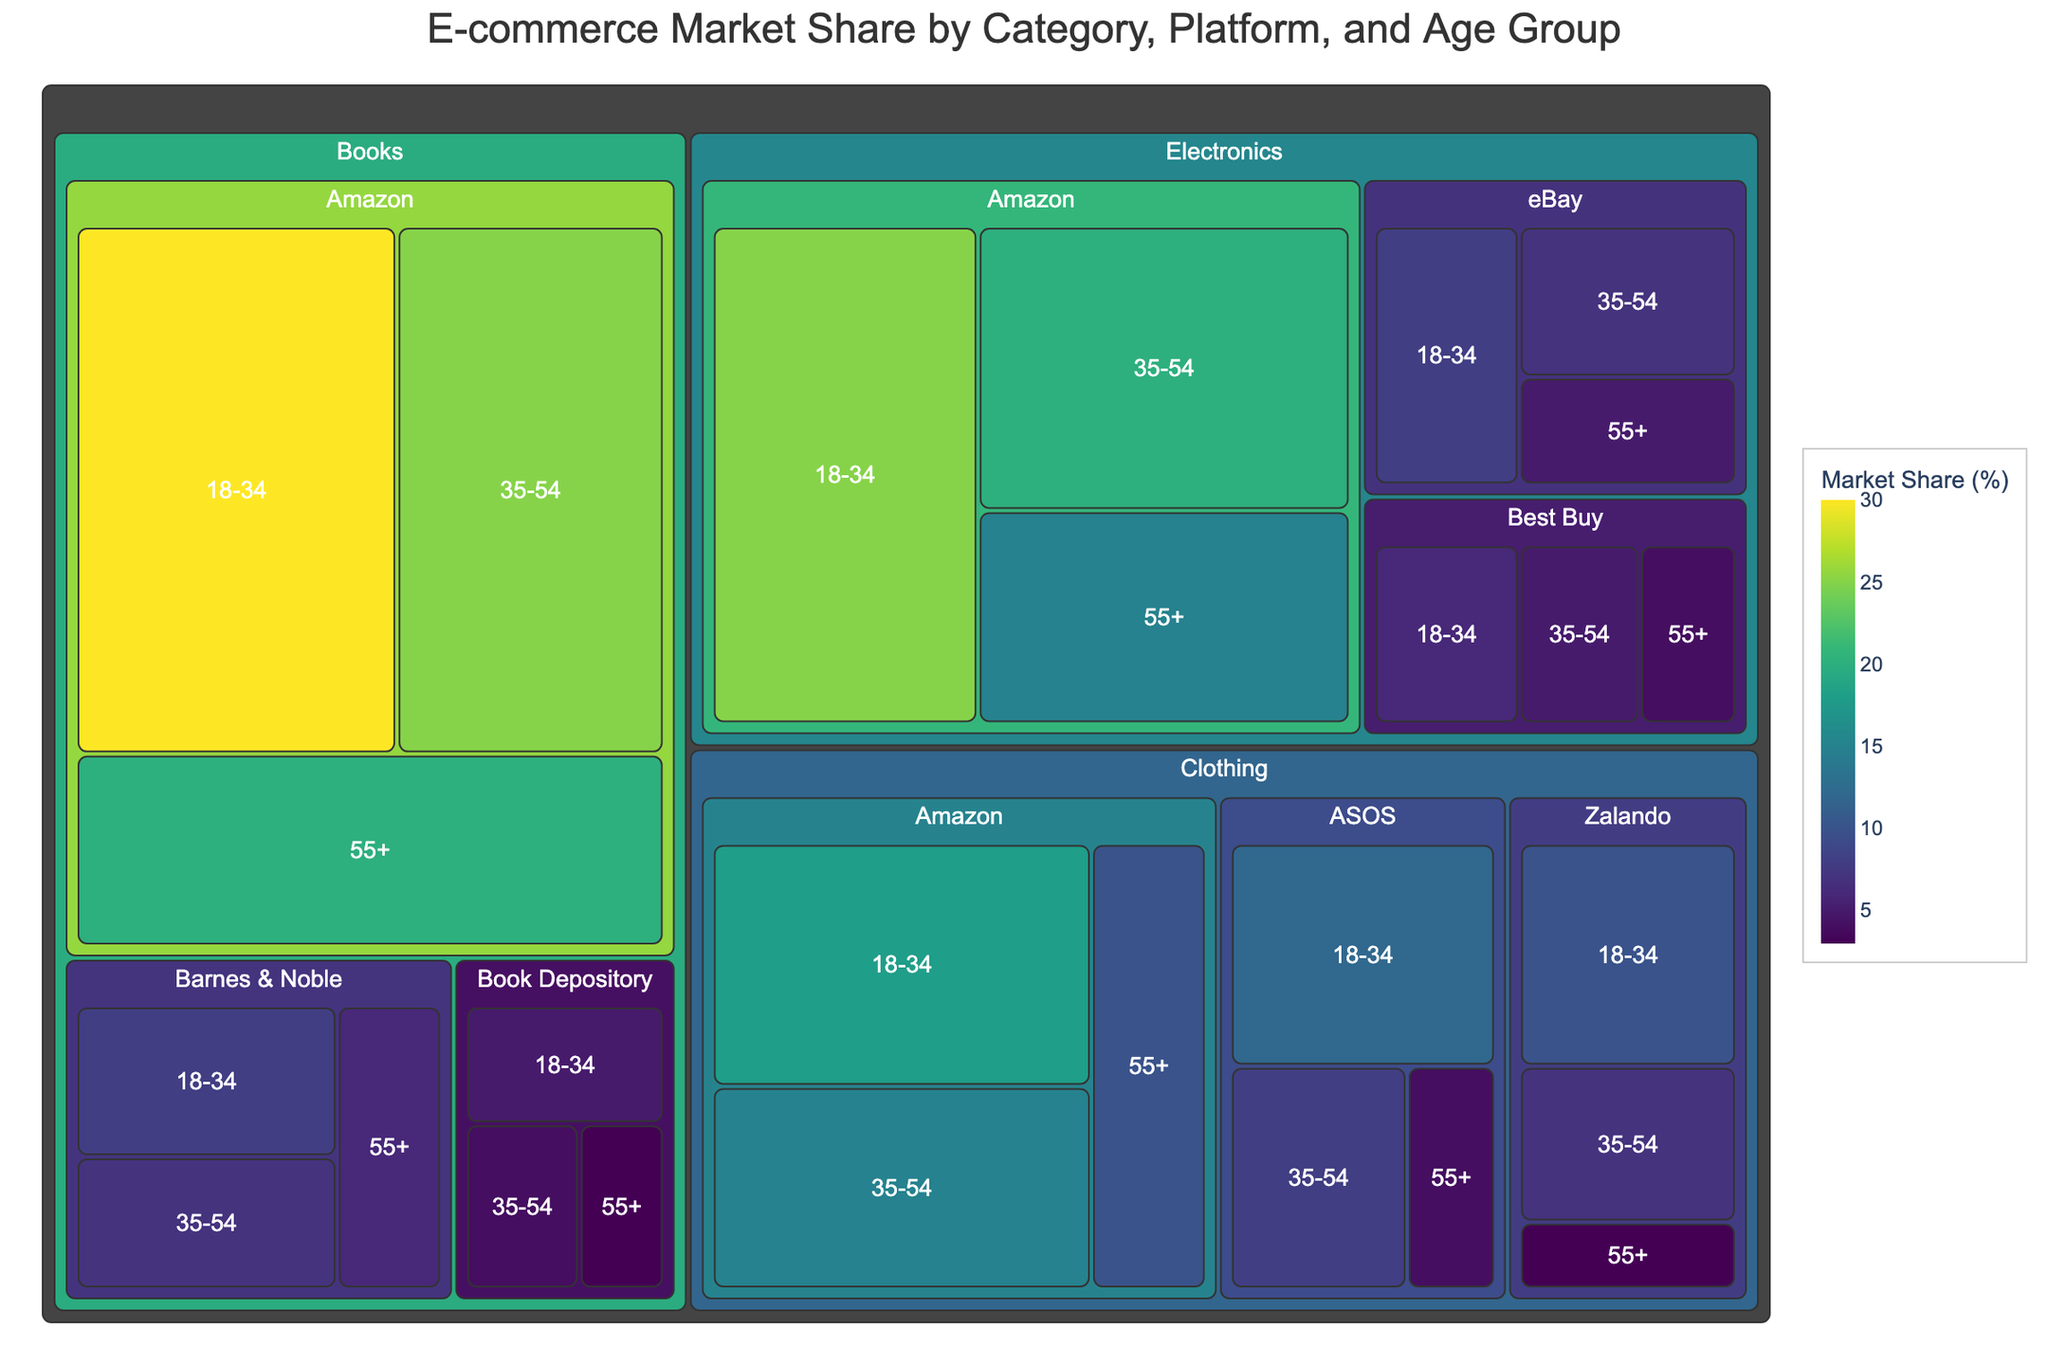What is the total market share of Amazon in the Electronics category? To calculate the total market share of Amazon in the Electronics category, we need to sum up the market shares for the 18-34, 35-54, and 55+ age groups. The values are 25, 20, and 15 respectively. Summing them gives 25 + 20 + 15 = 60.
Answer: 60 Which e-commerce platform holds the smallest market share for the 18-34 age group in the Books category? By examining the treemap, we locate the market share values for the Books category under the 18-34 age group. The platforms are Amazon (30), Barnes & Noble (8), and Book Depository (5). The smallest value is 5, which belongs to Book Depository.
Answer: Book Depository In the Clothing category, which platform has the highest market share in the 35-54 age group? For the Clothing category in the 35-54 age group, we find the market share values for the platforms: Amazon (15), ASOS (8), and Zalando (7). The highest value is 15, which belongs to Amazon.
Answer: Amazon What is the combined market share of eBay and Best Buy for the Electronics category across all age groups? First, we sum the market shares for eBay across all age groups in the Electronics category: 8 (18-34) + 7 (35-54) + 5 (55+) = 20. Then we sum the market shares for Best Buy across all age groups: 6 (18-34) + 5 (35-54) + 4 (55+) = 15. Adding these results gives 20 + 15 = 35.
Answer: 35 Comparing Amazon and ASOS platforms in the Clothing category for the 18-34 age group, which one has a greater market share, and by how much? We check the market shares of Amazon and ASOS in the Clothing category for the 18-34 age group: Amazon (18) and ASOS (12). The difference is calculated as 18 - 12 = 6.
Answer: Amazon, by 6 Rank the platforms for the Books category in the 55+ age group from highest to lowest market share. We find the market shares for the Books category in the 55+ age group for each platform: Amazon (20), Barnes & Noble (6), and Book Depository (3). Ranking them from highest to lowest gives: Amazon, Barnes & Noble, Book Depository.
Answer: Amazon, Barnes & Noble, Book Depository Which age group contributes the highest market share for Amazon in the Books category? Checking the values for Amazon in the Books category, we see the market shares for different age groups: 18-34 (30), 35-54 (25), and 55+ (20). The highest value is 30 for the 18-34 age group.
Answer: 18-34 What is the average market share of Zalando in the Clothing category across all age groups? To find the average, we sum the market shares for Zalando in the Clothing category across all age groups: 10 (18-34) + 7 (35-54) + 3 (55+) = 20. Then, we divide by the number of age groups, which is 3. Therefore, the average is 20 / 3 ≈ 6.67.
Answer: 6.67 Which category has the highest market share for Amazon among the 18-34 age group? We review Amazon's market share in the 18-34 age group for all categories: Electronics (25), Clothing (18), and Books (30). The highest is 30 in the Books category.
Answer: Books What is the difference in market share between Amazon and Barnes & Noble in the Books category for the 35-54 age group? We check the market shares for the Books category in the 35-54 age group: Amazon (25) and Barnes & Noble (7). The difference is calculated as 25 - 7 = 18.
Answer: 18 